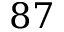<formula> <loc_0><loc_0><loc_500><loc_500>8 7</formula> 